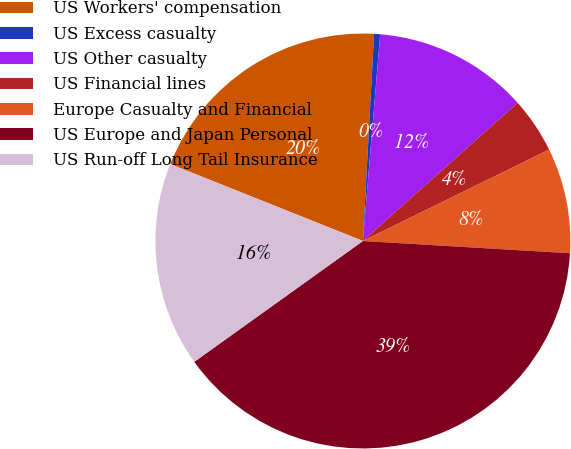Convert chart to OTSL. <chart><loc_0><loc_0><loc_500><loc_500><pie_chart><fcel>US Workers' compensation<fcel>US Excess casualty<fcel>US Other casualty<fcel>US Financial lines<fcel>Europe Casualty and Financial<fcel>US Europe and Japan Personal<fcel>US Run-off Long Tail Insurance<nl><fcel>19.81%<fcel>0.47%<fcel>12.07%<fcel>4.34%<fcel>8.2%<fcel>39.16%<fcel>15.94%<nl></chart> 